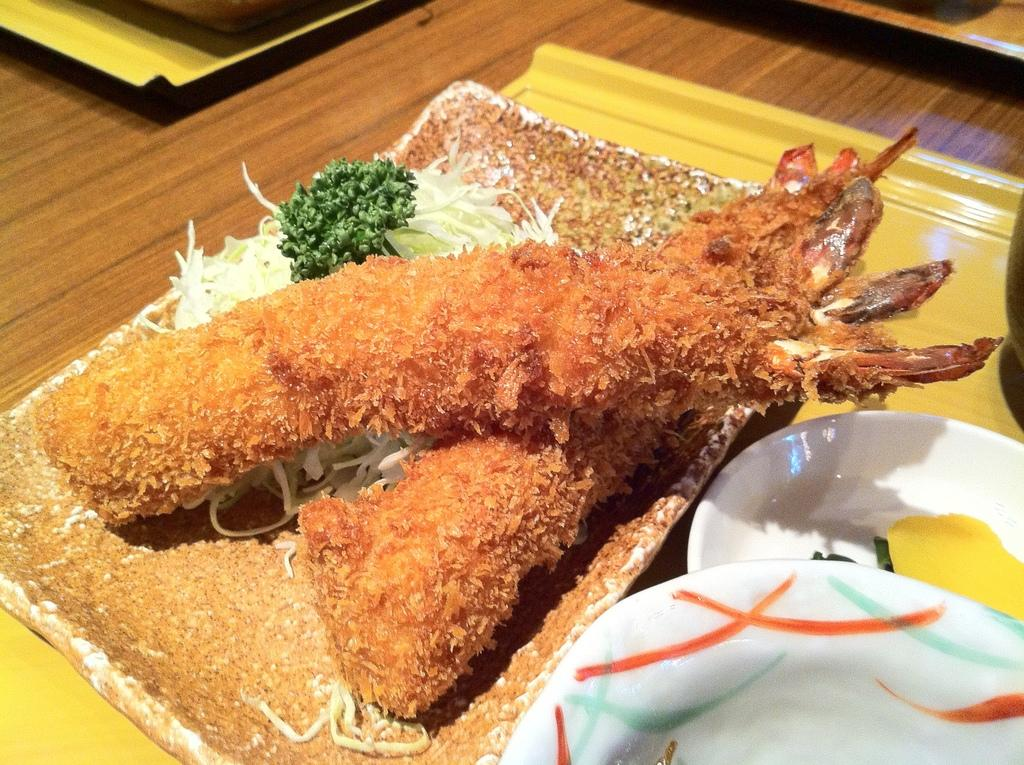What type of items can be seen in the image? There are food items in the image. What color is the bowl that contains the food items? There is a white color bowl in the image. What is the surface made of that the bowl and other objects are placed on? There are other objects on a wooden surface in the image. Can you tell me how many people are waiting at the airport in the image? There is no airport or people waiting in the image; it only contains food items, a white bowl, and other objects on a wooden surface. 